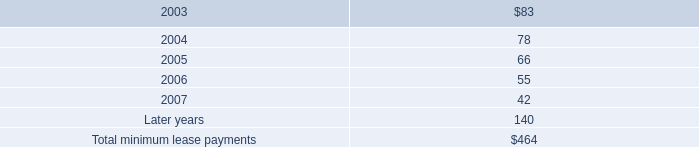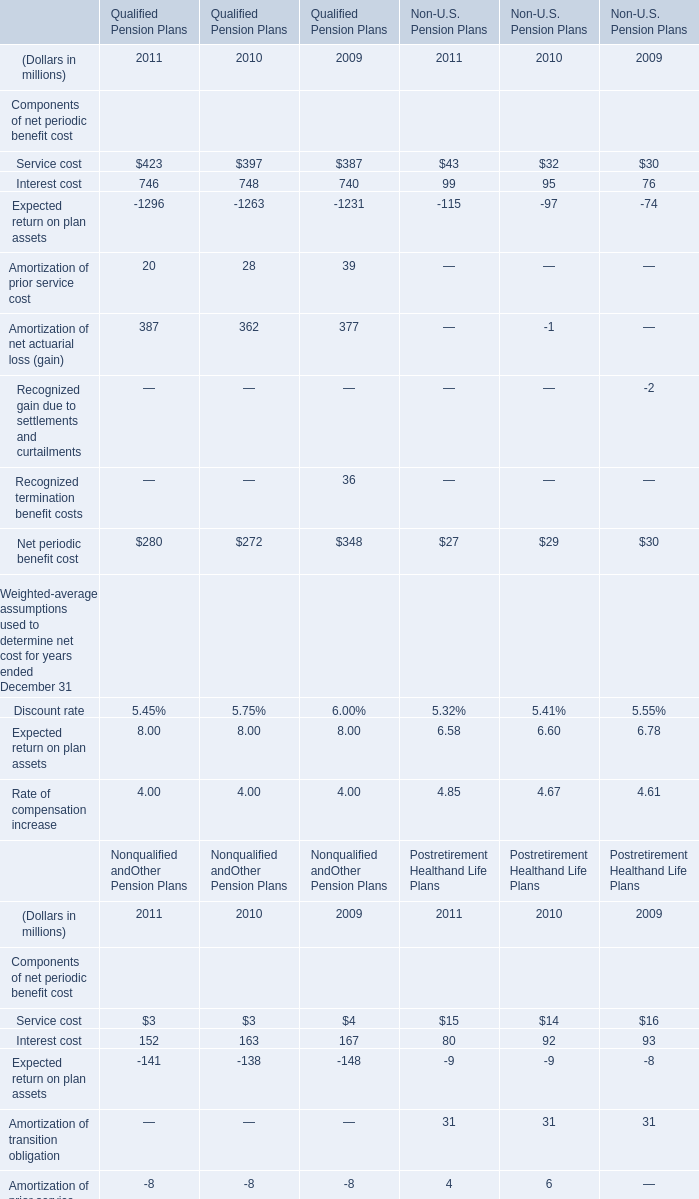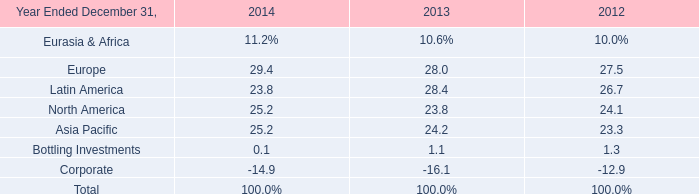What is the growing rate of Service cost in Qualified Pension Plans in the years with the least Amortization of net actuarial loss (gain) in Qualified Pension Plans? 
Computations: ((397 - 387) / 387)
Answer: 0.02584. 